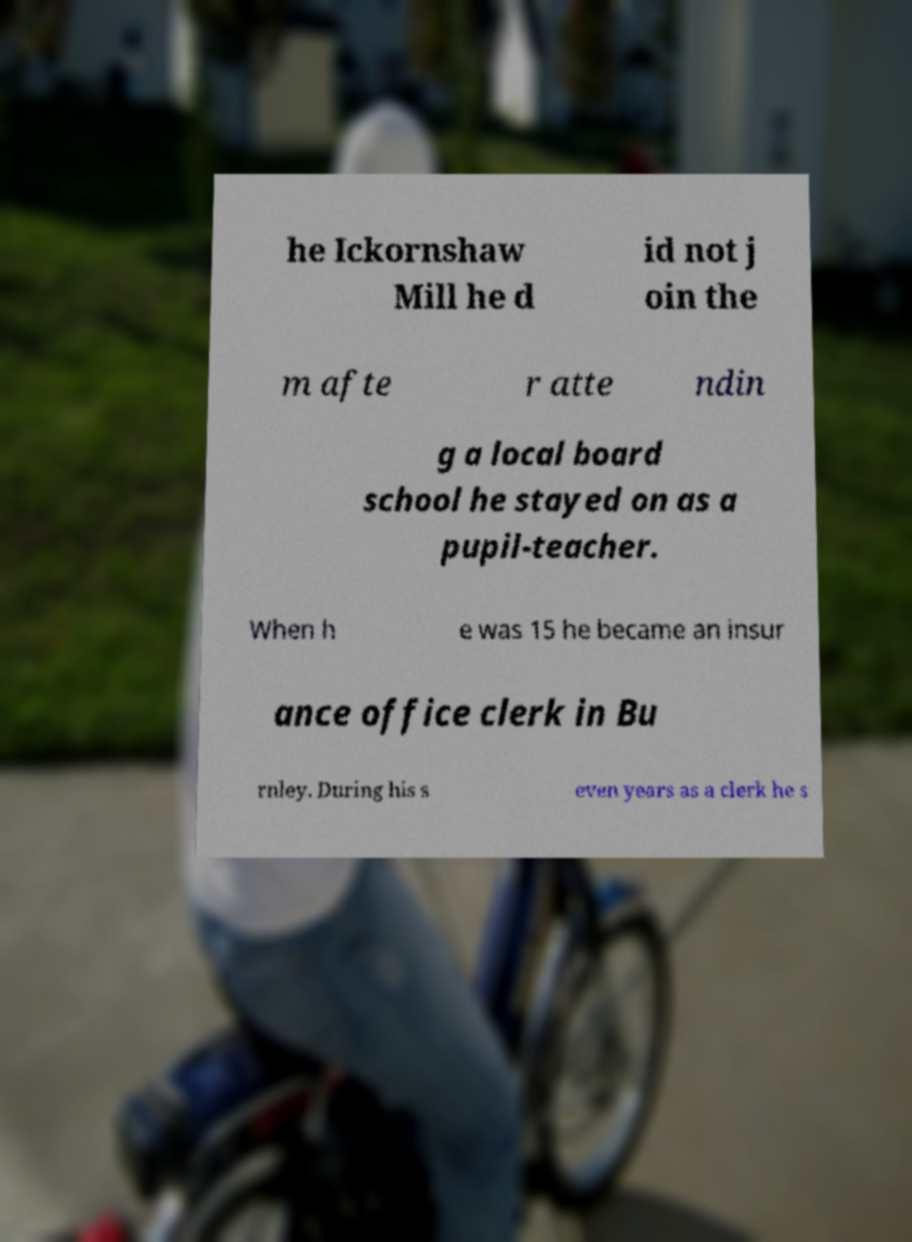What messages or text are displayed in this image? I need them in a readable, typed format. he Ickornshaw Mill he d id not j oin the m afte r atte ndin g a local board school he stayed on as a pupil-teacher. When h e was 15 he became an insur ance office clerk in Bu rnley. During his s even years as a clerk he s 